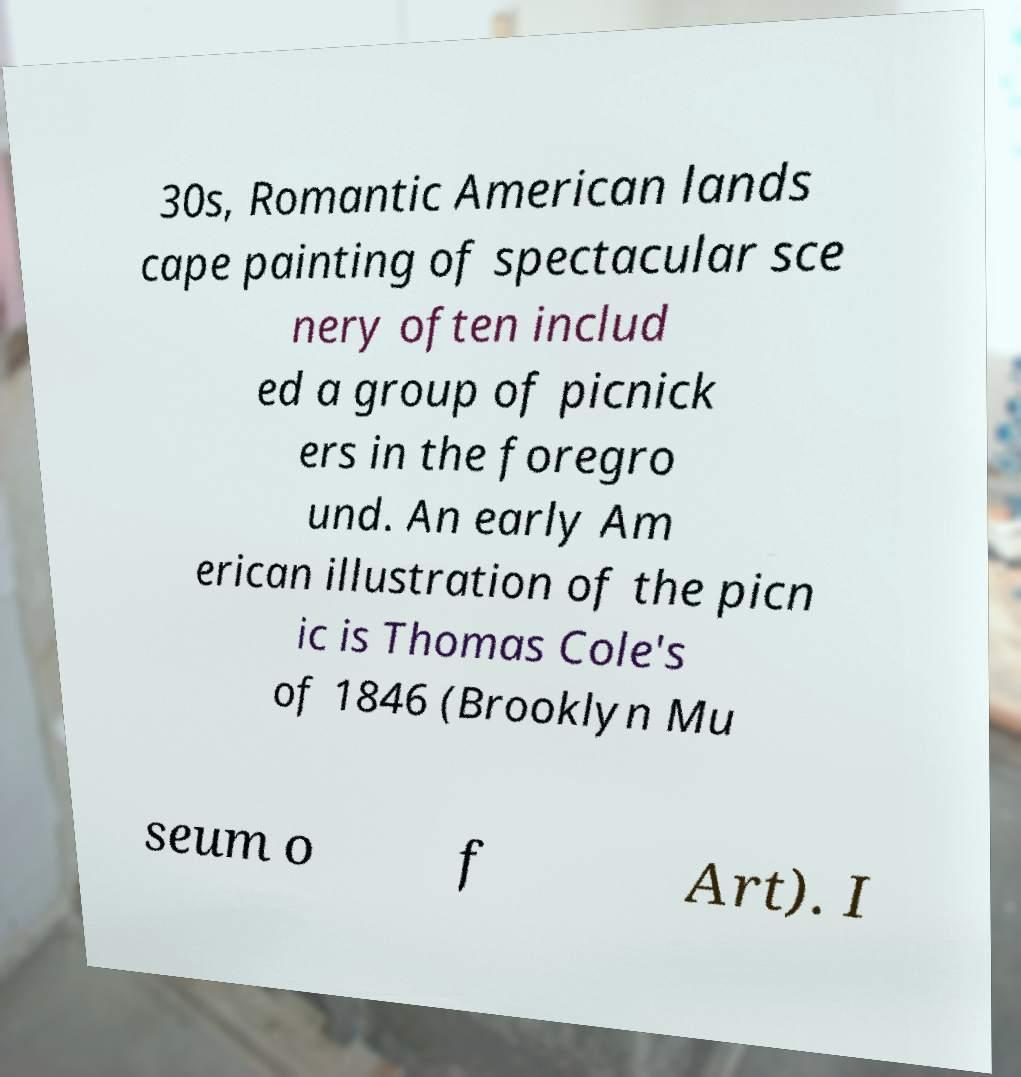Could you assist in decoding the text presented in this image and type it out clearly? 30s, Romantic American lands cape painting of spectacular sce nery often includ ed a group of picnick ers in the foregro und. An early Am erican illustration of the picn ic is Thomas Cole's of 1846 (Brooklyn Mu seum o f Art). I 